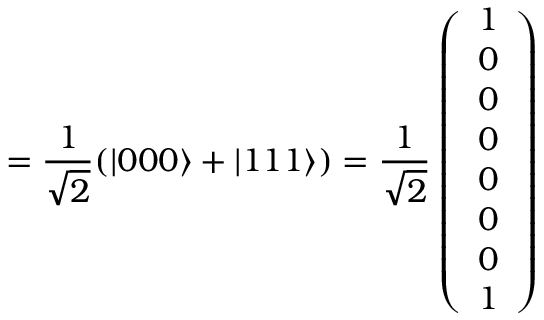<formula> <loc_0><loc_0><loc_500><loc_500>= \frac { 1 } { \sqrt { 2 } } ( | 0 0 0 \rangle + | 1 1 1 \rangle ) = \frac { 1 } { \sqrt { 2 } } \left ( \begin{array} { l } { 1 } \\ { 0 } \\ { 0 } \\ { 0 } \\ { 0 } \\ { 0 } \\ { 0 } \\ { 1 } \end{array} \right )</formula> 